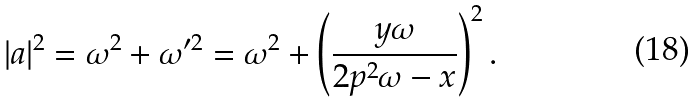<formula> <loc_0><loc_0><loc_500><loc_500>| a | ^ { 2 } = \omega ^ { 2 } + \omega ^ { \prime 2 } = \omega ^ { 2 } + \left ( \frac { y \omega } { 2 p ^ { 2 } \omega - x } \right ) ^ { 2 } .</formula> 